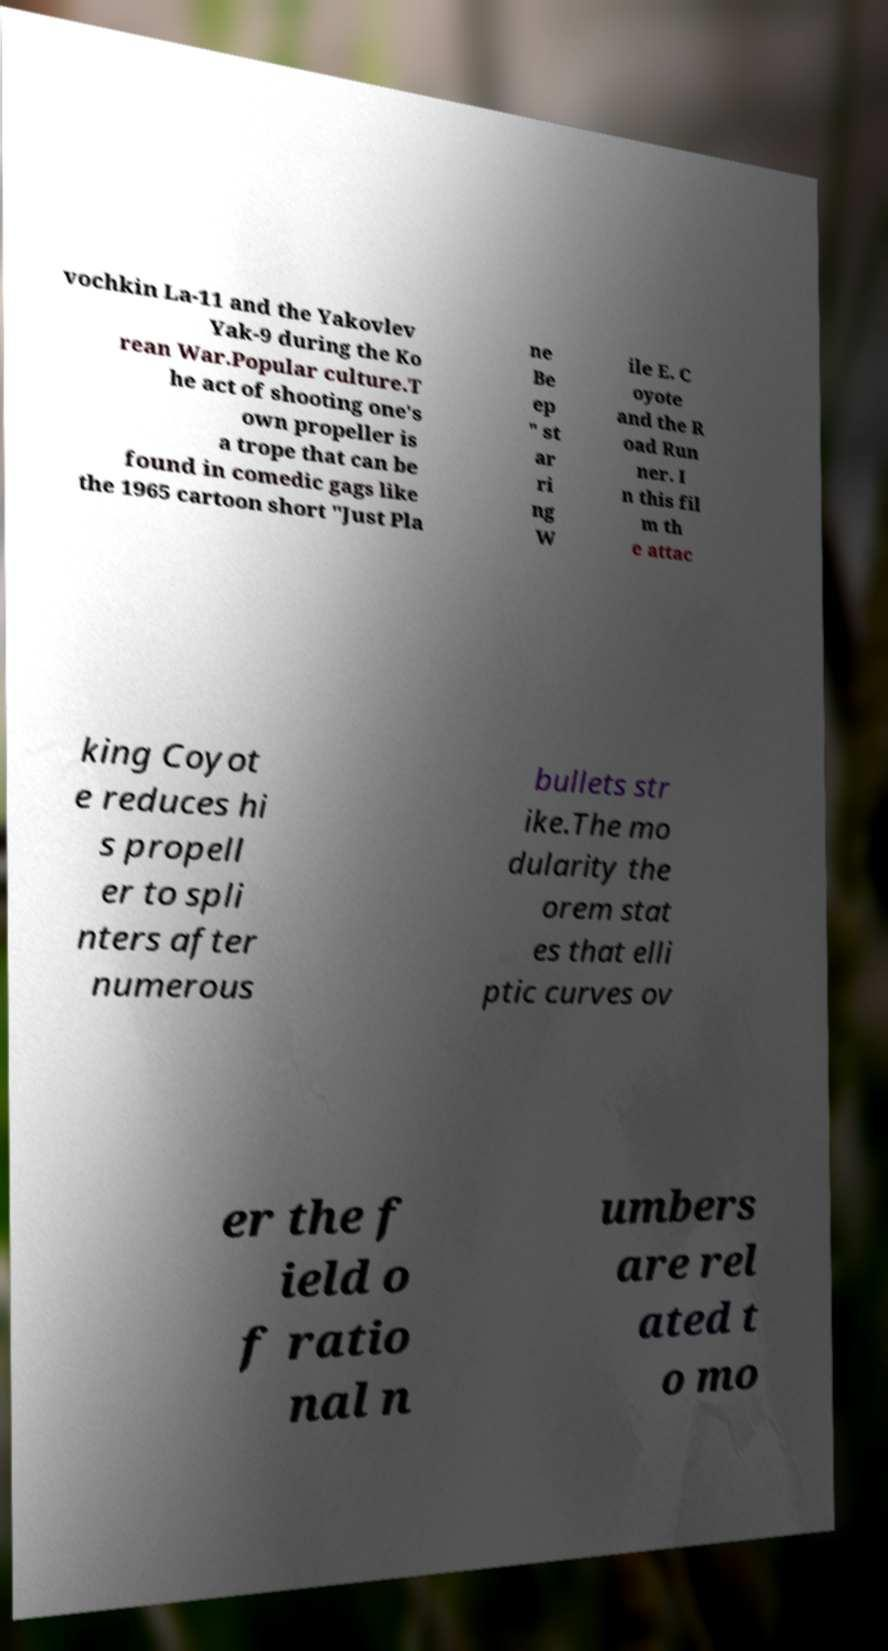Can you read and provide the text displayed in the image?This photo seems to have some interesting text. Can you extract and type it out for me? vochkin La-11 and the Yakovlev Yak-9 during the Ko rean War.Popular culture.T he act of shooting one's own propeller is a trope that can be found in comedic gags like the 1965 cartoon short "Just Pla ne Be ep " st ar ri ng W ile E. C oyote and the R oad Run ner. I n this fil m th e attac king Coyot e reduces hi s propell er to spli nters after numerous bullets str ike.The mo dularity the orem stat es that elli ptic curves ov er the f ield o f ratio nal n umbers are rel ated t o mo 